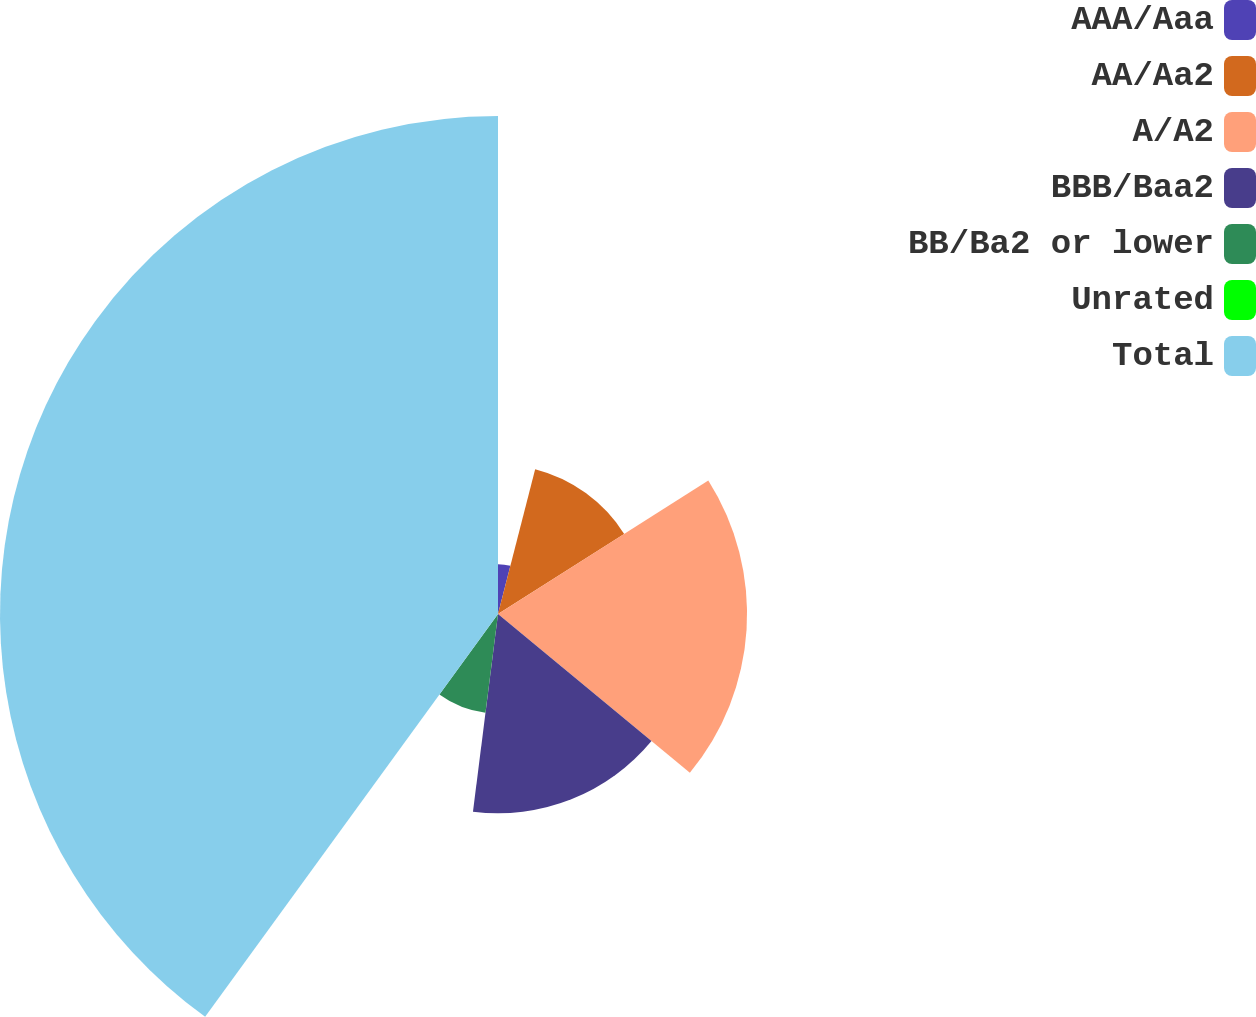Convert chart. <chart><loc_0><loc_0><loc_500><loc_500><pie_chart><fcel>AAA/Aaa<fcel>AA/Aa2<fcel>A/A2<fcel>BBB/Baa2<fcel>BB/Ba2 or lower<fcel>Unrated<fcel>Total<nl><fcel>4.0%<fcel>12.0%<fcel>20.0%<fcel>16.0%<fcel>8.0%<fcel>0.0%<fcel>39.99%<nl></chart> 